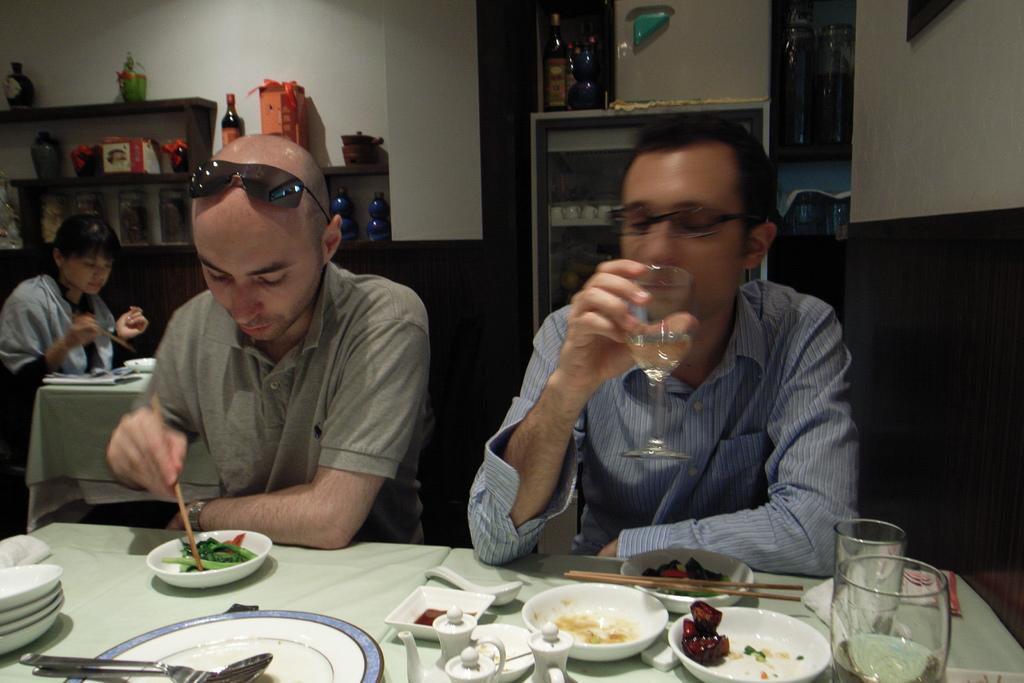Can you describe this image briefly? In this picture we can see two men are sitting in front of a table, there are plates, bowls and glasses on this table, a man on the left side is holding chopsticks, a man on the right side is holding a glass of drink, there is some food in these bowls, on the left side there is another person, in the background there are shelves and a wall, we can see flower vases and other things present on these shelves, we can see a bottle in the middle, at the bottom there is a spoon. 